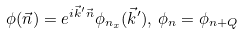Convert formula to latex. <formula><loc_0><loc_0><loc_500><loc_500>\phi ( \vec { n } ) = e ^ { i \vec { k } ^ { \prime } \vec { n } } \phi _ { n _ { x } } ( \vec { k } ^ { \prime } ) , \, \phi _ { n } = \phi _ { n + Q }</formula> 